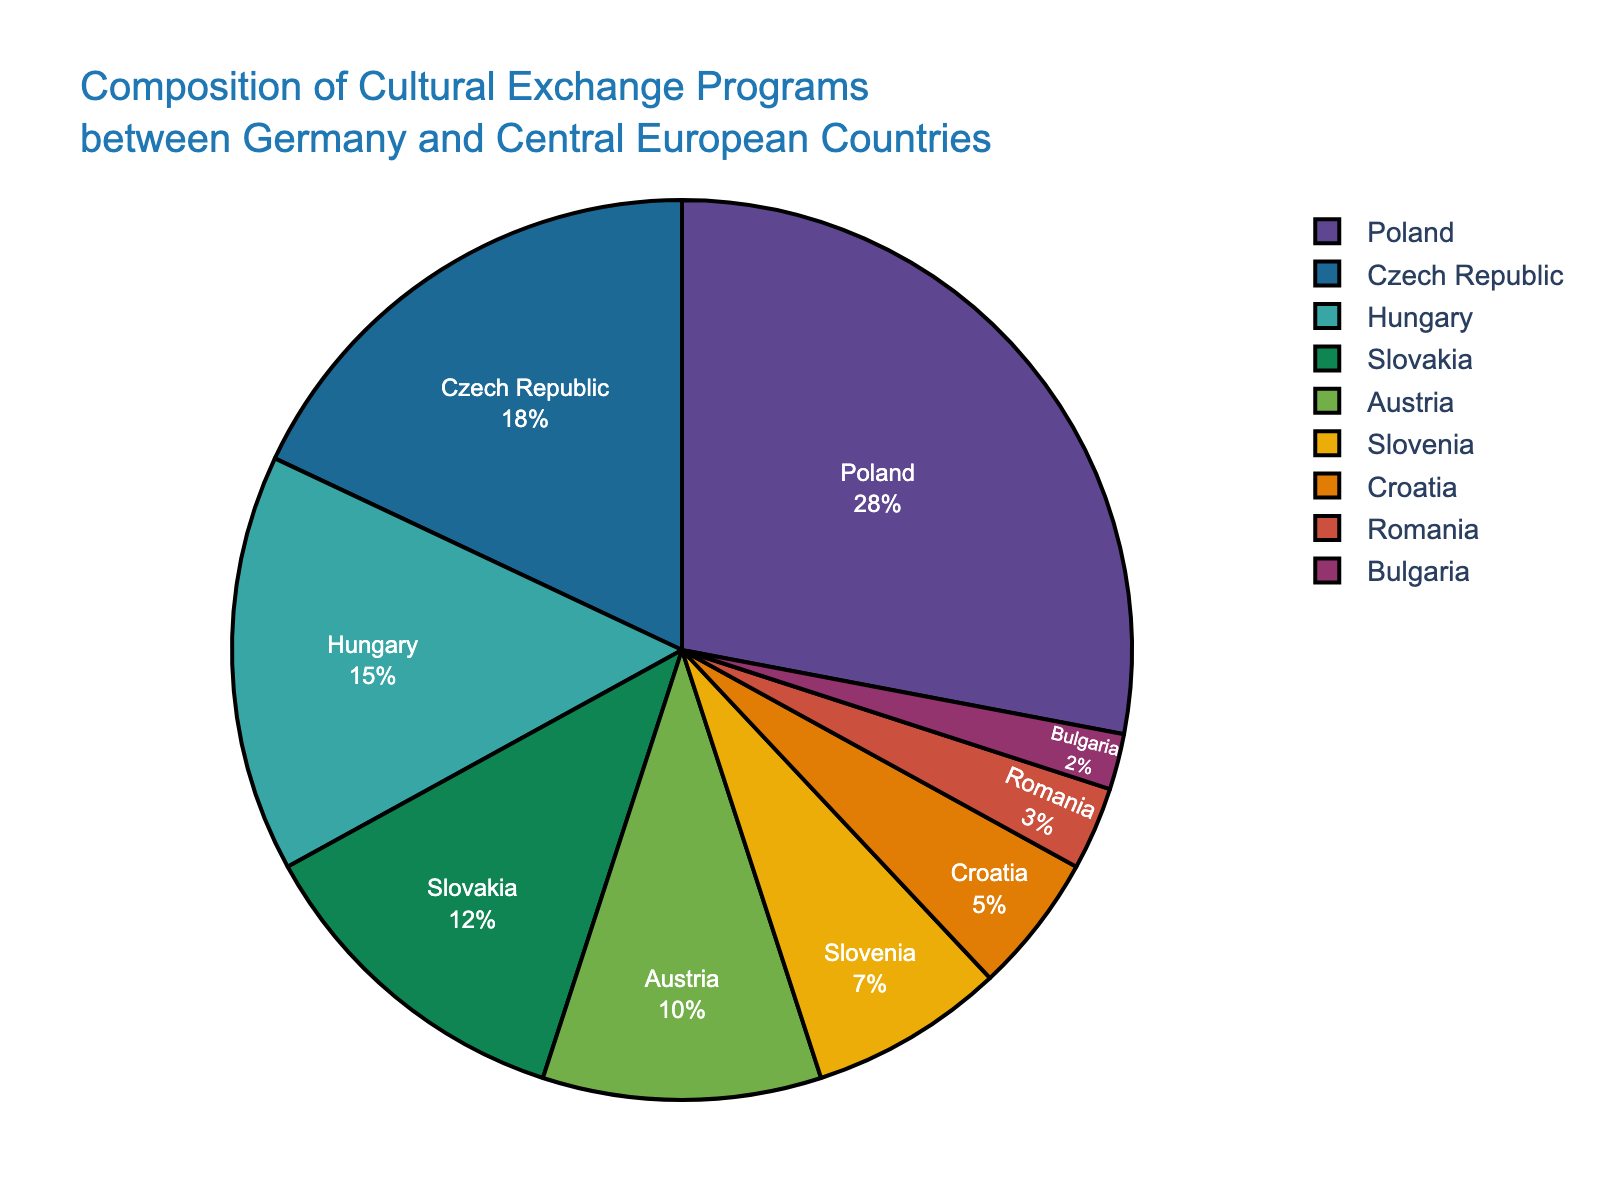What's the percentage of cultural exchange programs involving Poland and Hungary combined? The percentage for Poland is 28% and for Hungary is 15%. Combining these values: 28% + 15% = 43%.
Answer: 43% Which country has a higher percentage of cultural exchange programs: Austria or Slovenia? Austria has a percentage of 10%, while Slovenia has 7%. Since 10% > 7%, Austria has a higher percentage.
Answer: Austria What is the total percentage of the countries with the smallest contributions (Romania and Bulgaria)? The percentage for Romania is 3% and for Bulgaria is 2%. Combining these values: 3% + 2% = 5%.
Answer: 5% Which country has the largest portion of cultural exchange programs, and what is its percentage? Poland has the largest portion with 28% of the cultural exchange programs.
Answer: Poland, 28% How does the percentage of cultural exchange programs with Slovakia compare to that with Croatia? Slovakia has a percentage of 12% while Croatia has 5%. Since 12% > 5%, Slovakia's percentage is higher.
Answer: Slovakia What's the combined percentage for the countries with contributions less than 10%? The countries with contributions less than 10% are Slovenia (7%), Croatia (5%), Romania (3%), and Bulgaria (2%). Combining these values: 7% + 5% + 3% + 2% = 17%.
Answer: 17% Which countries have a percentage of cultural exchange programs between Germany and Central European countries that is greater than 15%? Poland (28%) and the Czech Republic (18%) both have percentages greater than 15%.
Answer: Poland, Czech Republic Compare the sum of percentages for Poland and Hungary to that of the Czech Republic and Slovakia. Which sum is greater? Poland and Hungary combined have 28% + 15% = 43%. The Czech Republic and Slovakia combined have 18% + 12% = 30%. Since 43% > 30%, Poland and Hungary have a greater combined percentage.
Answer: Poland and Hungary What is the percentage difference between the country with the highest and the lowest cultural exchange programs? The highest is Poland (28%) and the lowest is Bulgaria (2%). The difference is: 28% - 2% = 26%.
Answer: 26% Which country contributes more to cultural exchange programs, Slovenia or Croatia, and by what percentage? Slovenia contributes 7% and Croatia 5%. The difference is: 7% - 5% = 2%. Hence, Slovenia contributes 2% more than Croatia.
Answer: Slovenia, 2% 